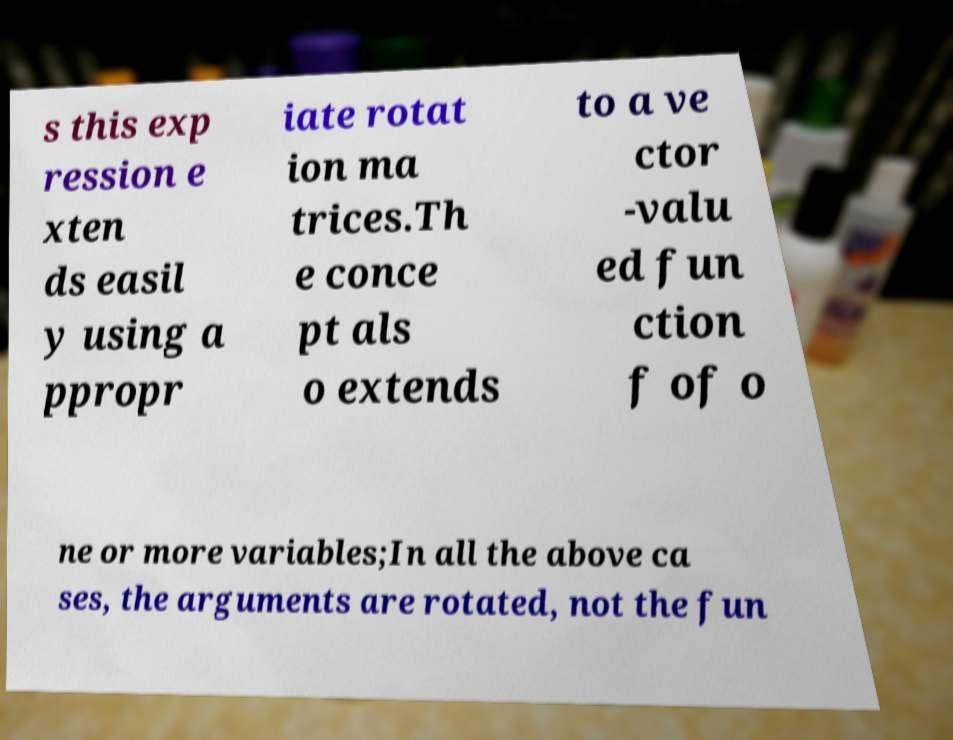Could you assist in decoding the text presented in this image and type it out clearly? s this exp ression e xten ds easil y using a ppropr iate rotat ion ma trices.Th e conce pt als o extends to a ve ctor -valu ed fun ction f of o ne or more variables;In all the above ca ses, the arguments are rotated, not the fun 